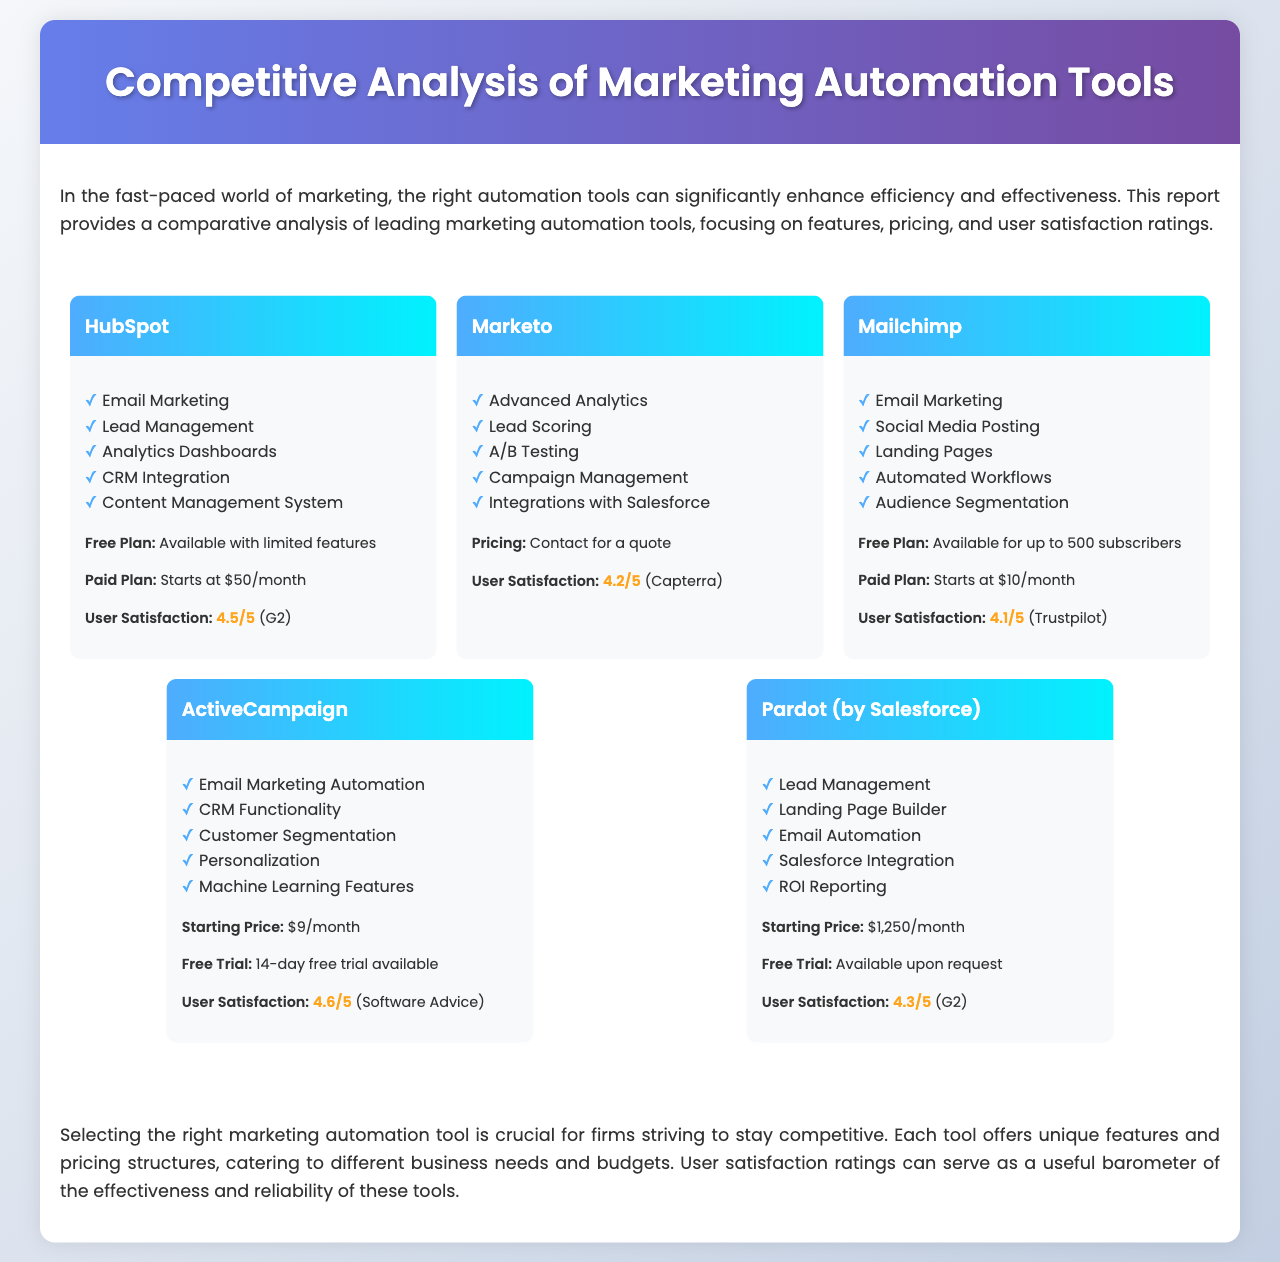What is the user satisfaction rating for HubSpot? The user satisfaction rating for HubSpot is provided in the document as 4.5/5 according to G2.
Answer: 4.5/5 What features are included in Mailchimp? The document lists five features under Mailchimp, including Email Marketing and Audience Segmentation.
Answer: Email Marketing, Social Media Posting, Landing Pages, Automated Workflows, Audience Segmentation What is the starting price for ActiveCampaign? The document states that the starting price for ActiveCampaign is $9/month.
Answer: $9/month Which marketing automation tool has the highest user satisfaction rating? By comparing the user satisfaction ratings mentioned in the document, ActiveCampaign with 4.6/5 has the highest rating.
Answer: 4.6/5 What is the free plan limit for Mailchimp? The document specifies that the free plan for Mailchimp is available for up to 500 subscribers.
Answer: Up to 500 subscribers What is the primary integration feature for Pardot? The document notes that Pardot has Salesforce Integration as a key feature.
Answer: Salesforce Integration What pricing model does Marketo follow? The document states that Marketo's pricing model requires users to contact for a quote, indicating it is customized.
Answer: Contact for a quote Which tool provides a 14-day free trial? The analysis mentions that ActiveCampaign offers a 14-day free trial.
Answer: 14-day free trial What are the advanced features offered by Marketo? The document lists five advanced features of Marketo, such as Lead Scoring and A/B Testing.
Answer: Advanced Analytics, Lead Scoring, A/B Testing, Campaign Management, Integrations with Salesforce 